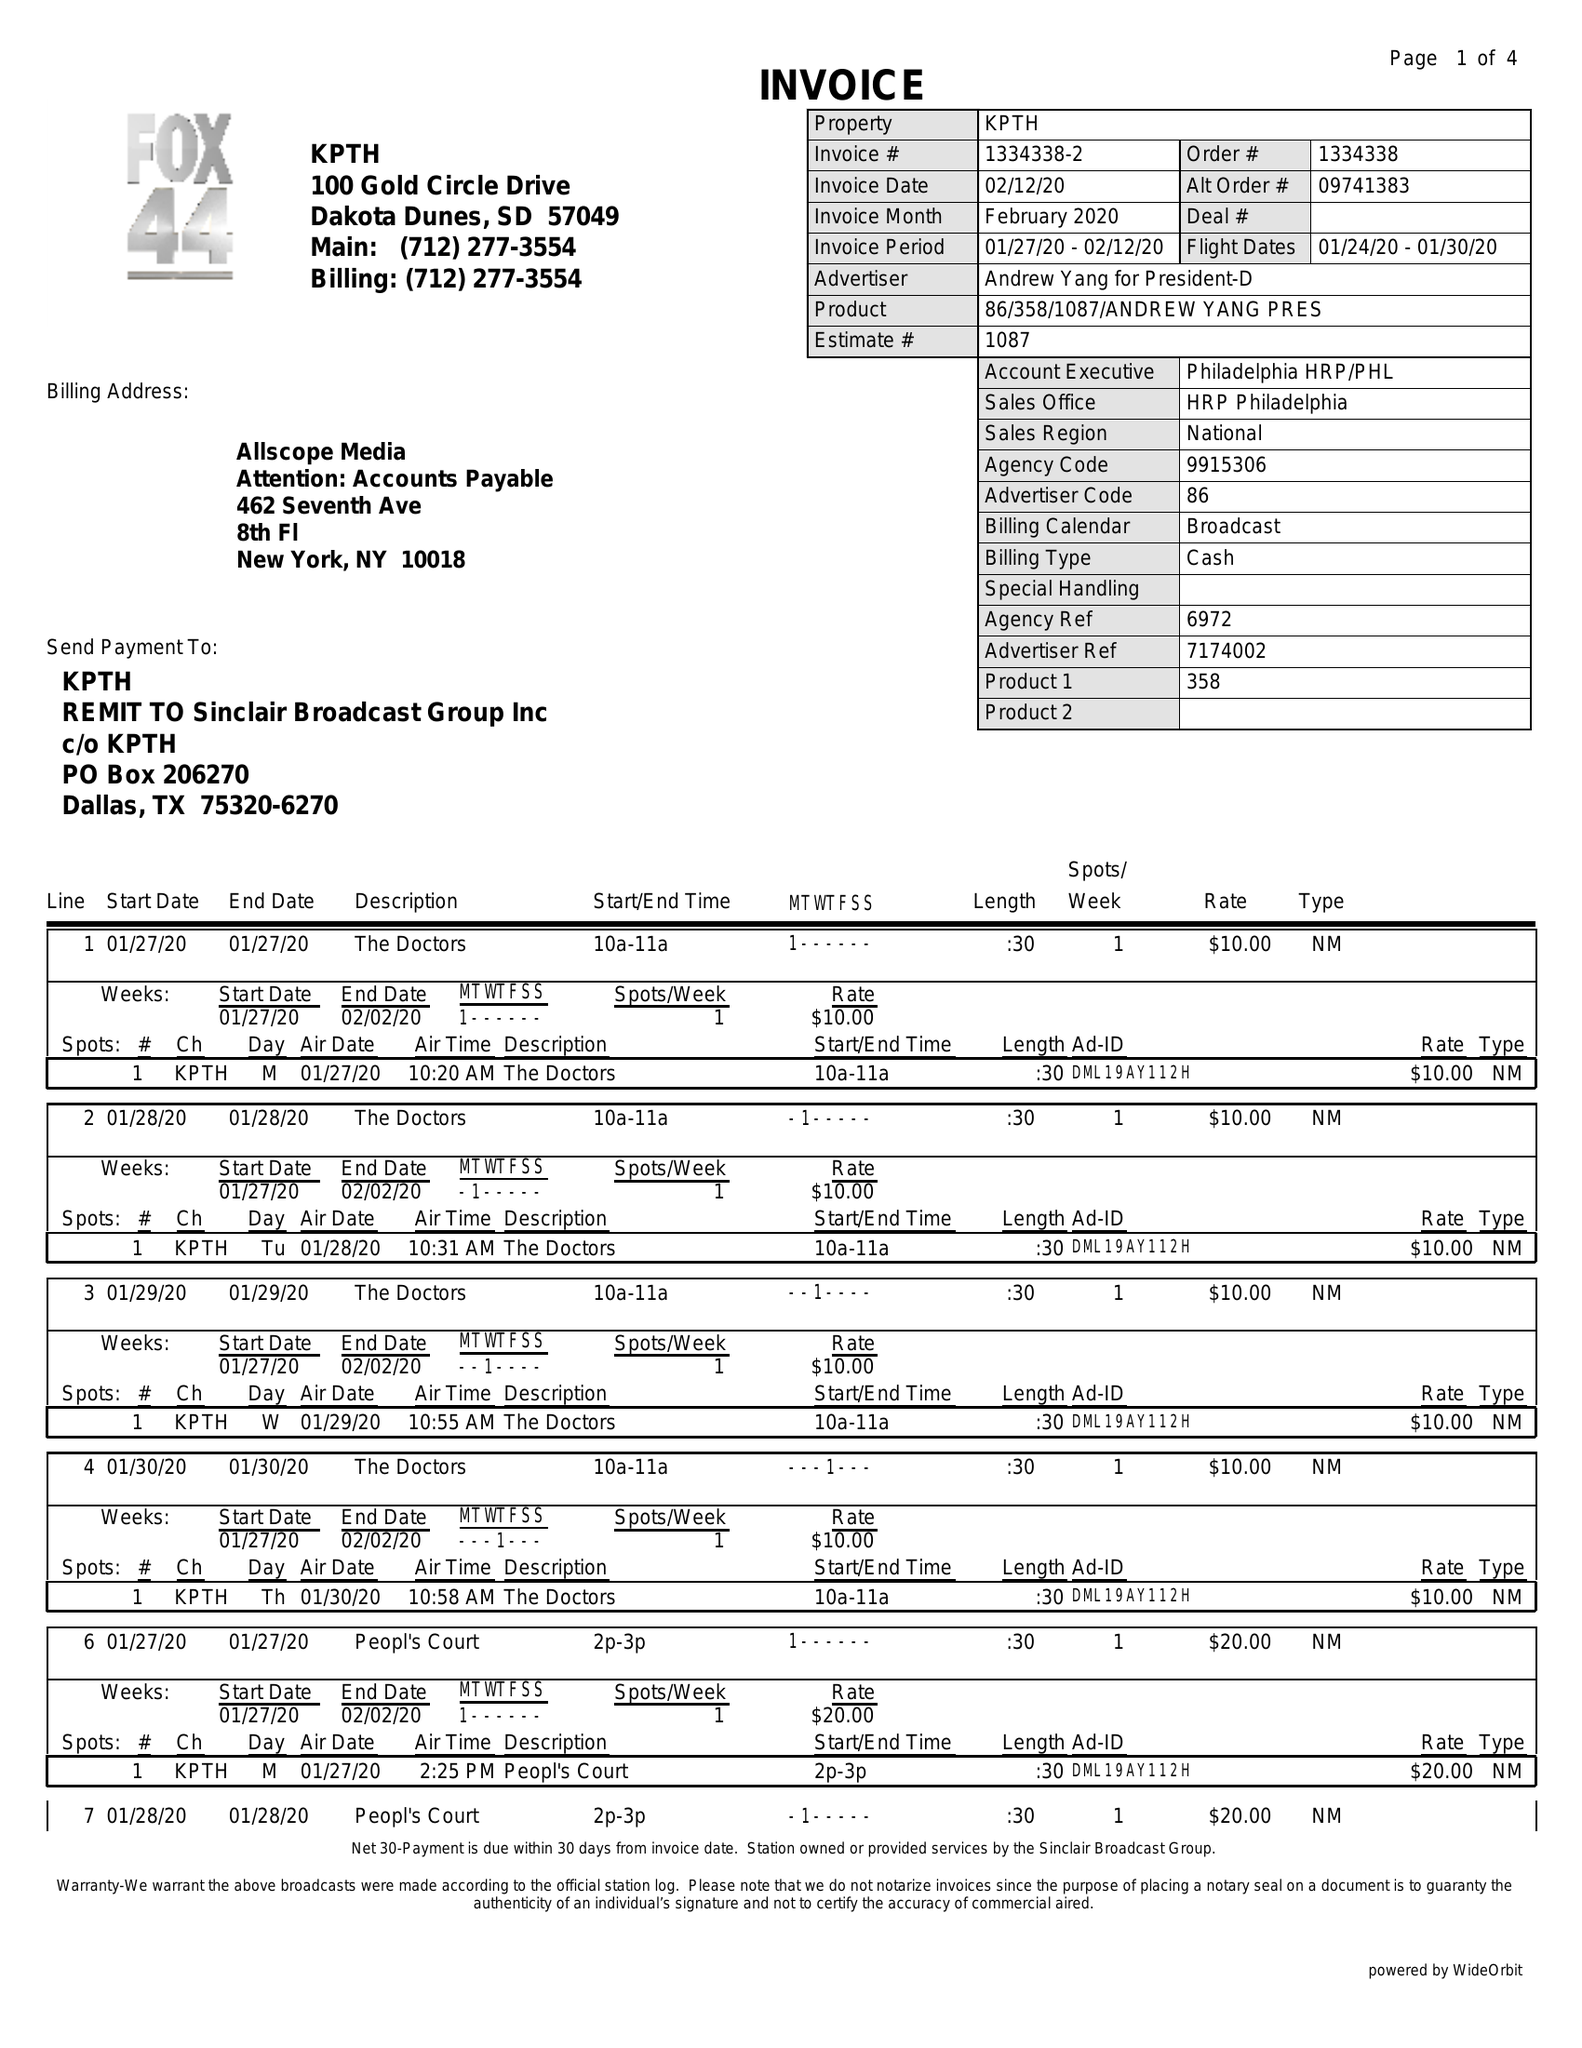What is the value for the contract_num?
Answer the question using a single word or phrase. 1334338 